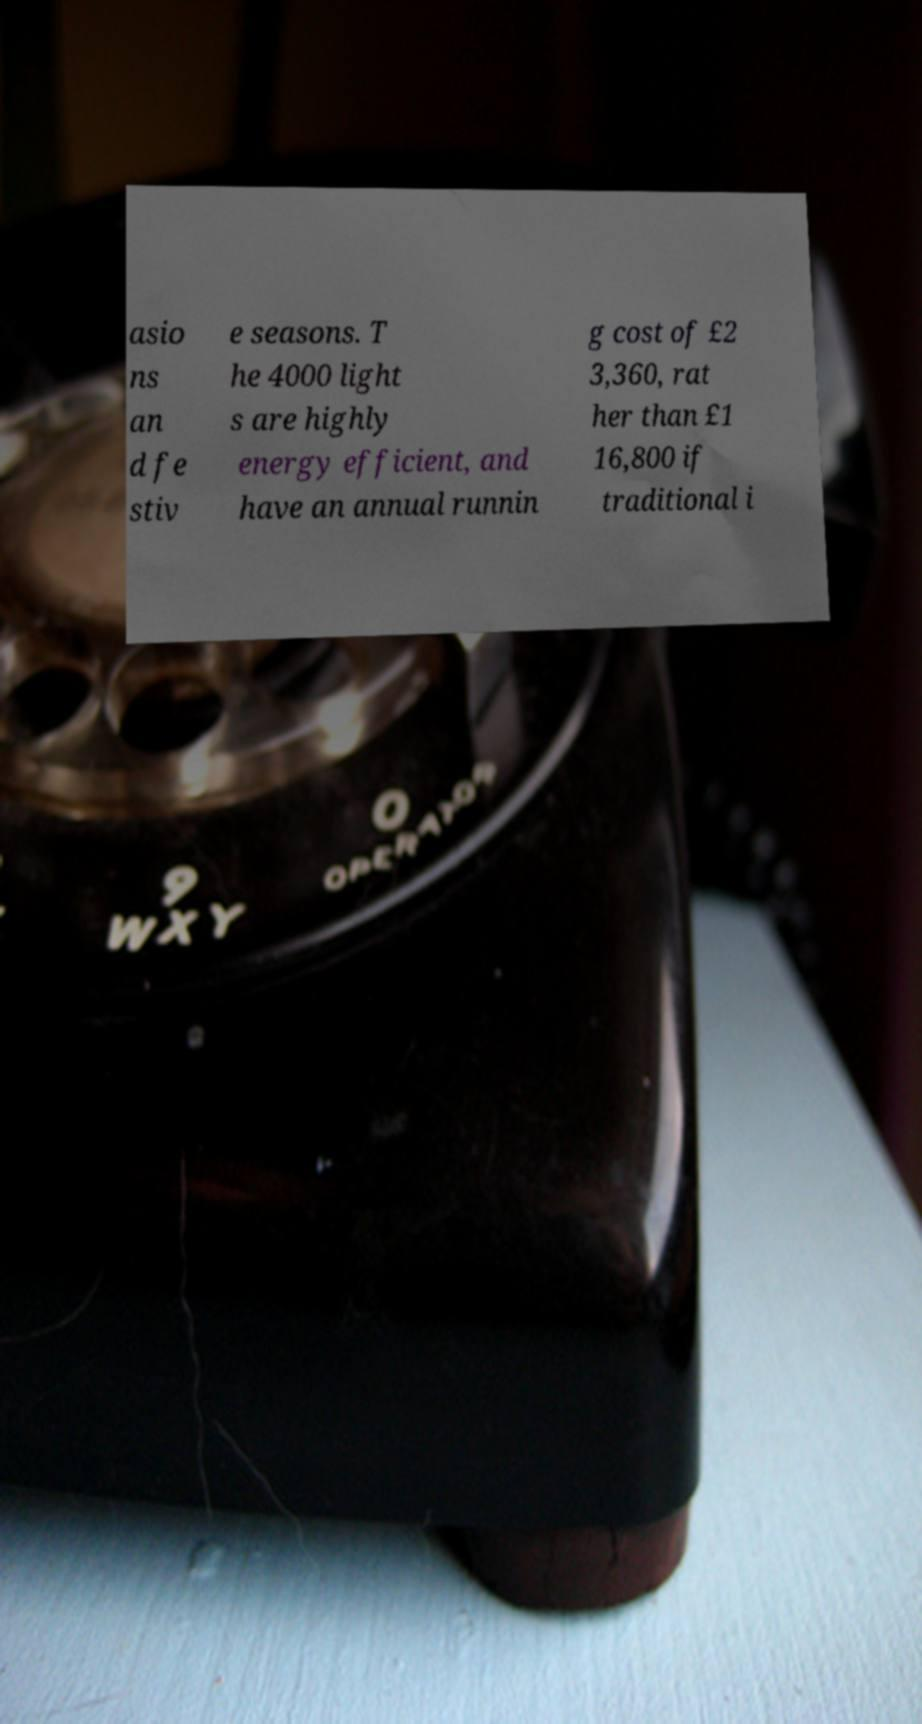There's text embedded in this image that I need extracted. Can you transcribe it verbatim? asio ns an d fe stiv e seasons. T he 4000 light s are highly energy efficient, and have an annual runnin g cost of £2 3,360, rat her than £1 16,800 if traditional i 